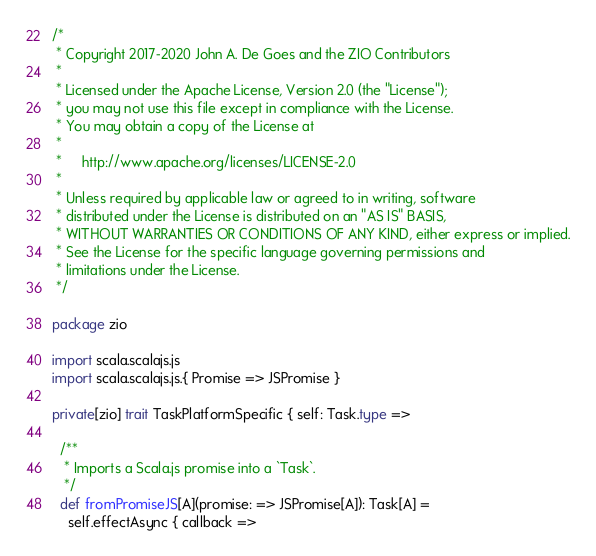Convert code to text. <code><loc_0><loc_0><loc_500><loc_500><_Scala_>/*
 * Copyright 2017-2020 John A. De Goes and the ZIO Contributors
 *
 * Licensed under the Apache License, Version 2.0 (the "License");
 * you may not use this file except in compliance with the License.
 * You may obtain a copy of the License at
 *
 *     http://www.apache.org/licenses/LICENSE-2.0
 *
 * Unless required by applicable law or agreed to in writing, software
 * distributed under the License is distributed on an "AS IS" BASIS,
 * WITHOUT WARRANTIES OR CONDITIONS OF ANY KIND, either express or implied.
 * See the License for the specific language governing permissions and
 * limitations under the License.
 */

package zio

import scala.scalajs.js
import scala.scalajs.js.{ Promise => JSPromise }

private[zio] trait TaskPlatformSpecific { self: Task.type =>

  /**
   * Imports a Scala.js promise into a `Task`.
   */
  def fromPromiseJS[A](promise: => JSPromise[A]): Task[A] =
    self.effectAsync { callback =></code> 